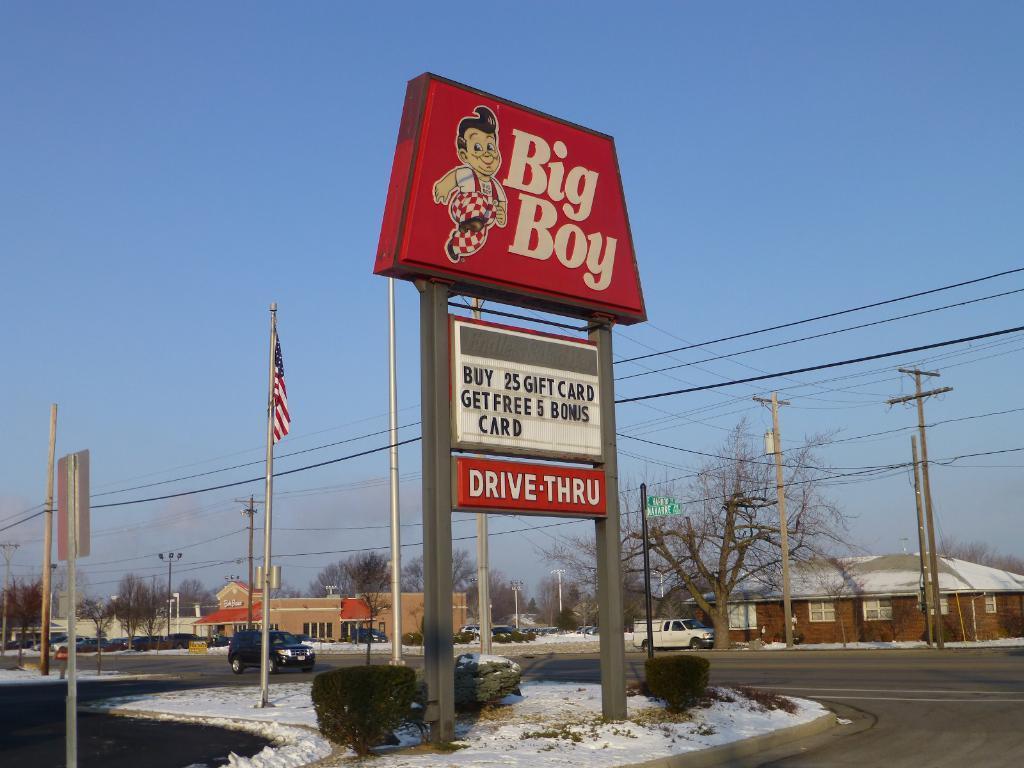Describe this image in one or two sentences. In the picture I can see boards which has something written on them, the snow, wires attached to poles, houses, trees, vehicles on the road, a flag and some other objects. In the background I can see the sky. 